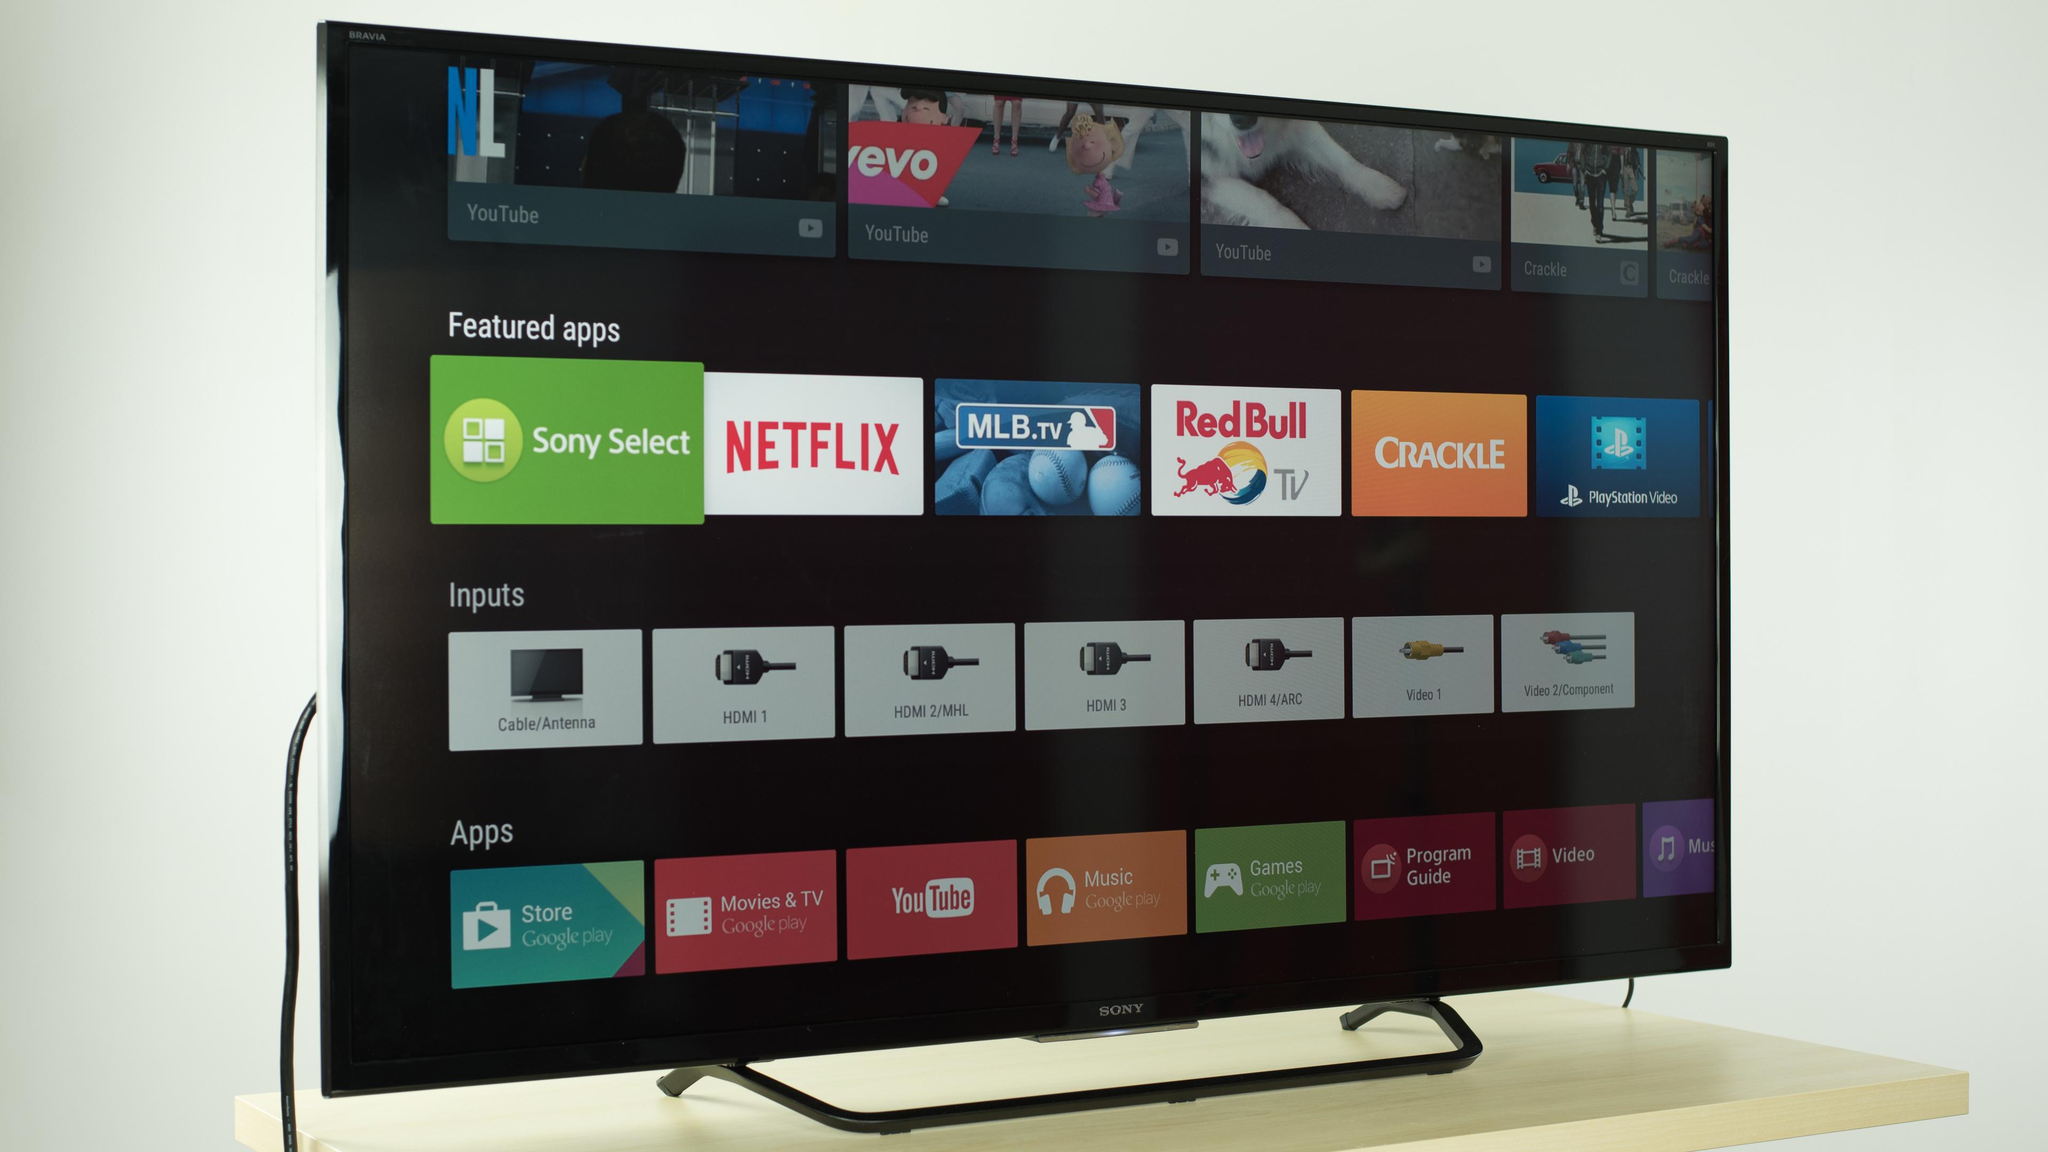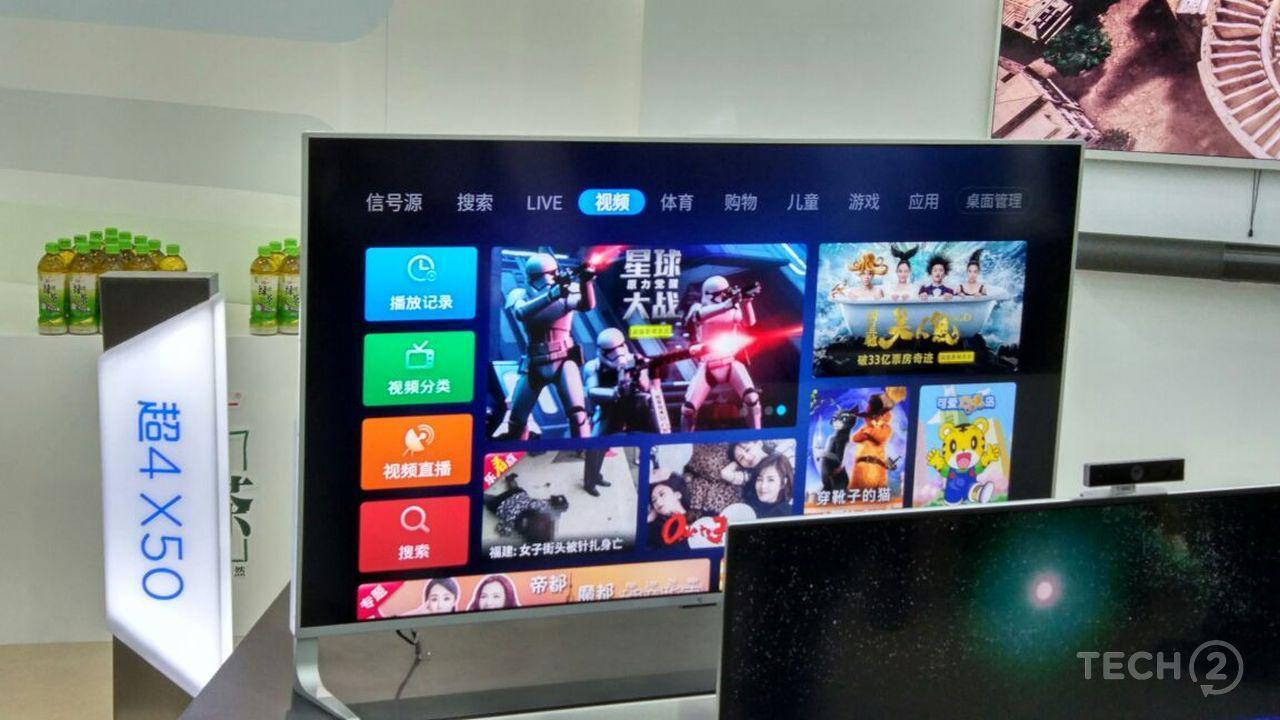The first image is the image on the left, the second image is the image on the right. For the images displayed, is the sentence "There are three monitors increasing in size with identical video being broadcast." factually correct? Answer yes or no. No. The first image is the image on the left, the second image is the image on the right. Evaluate the accuracy of this statement regarding the images: "The right image contains more operating screens than the left image.". Is it true? Answer yes or no. No. 